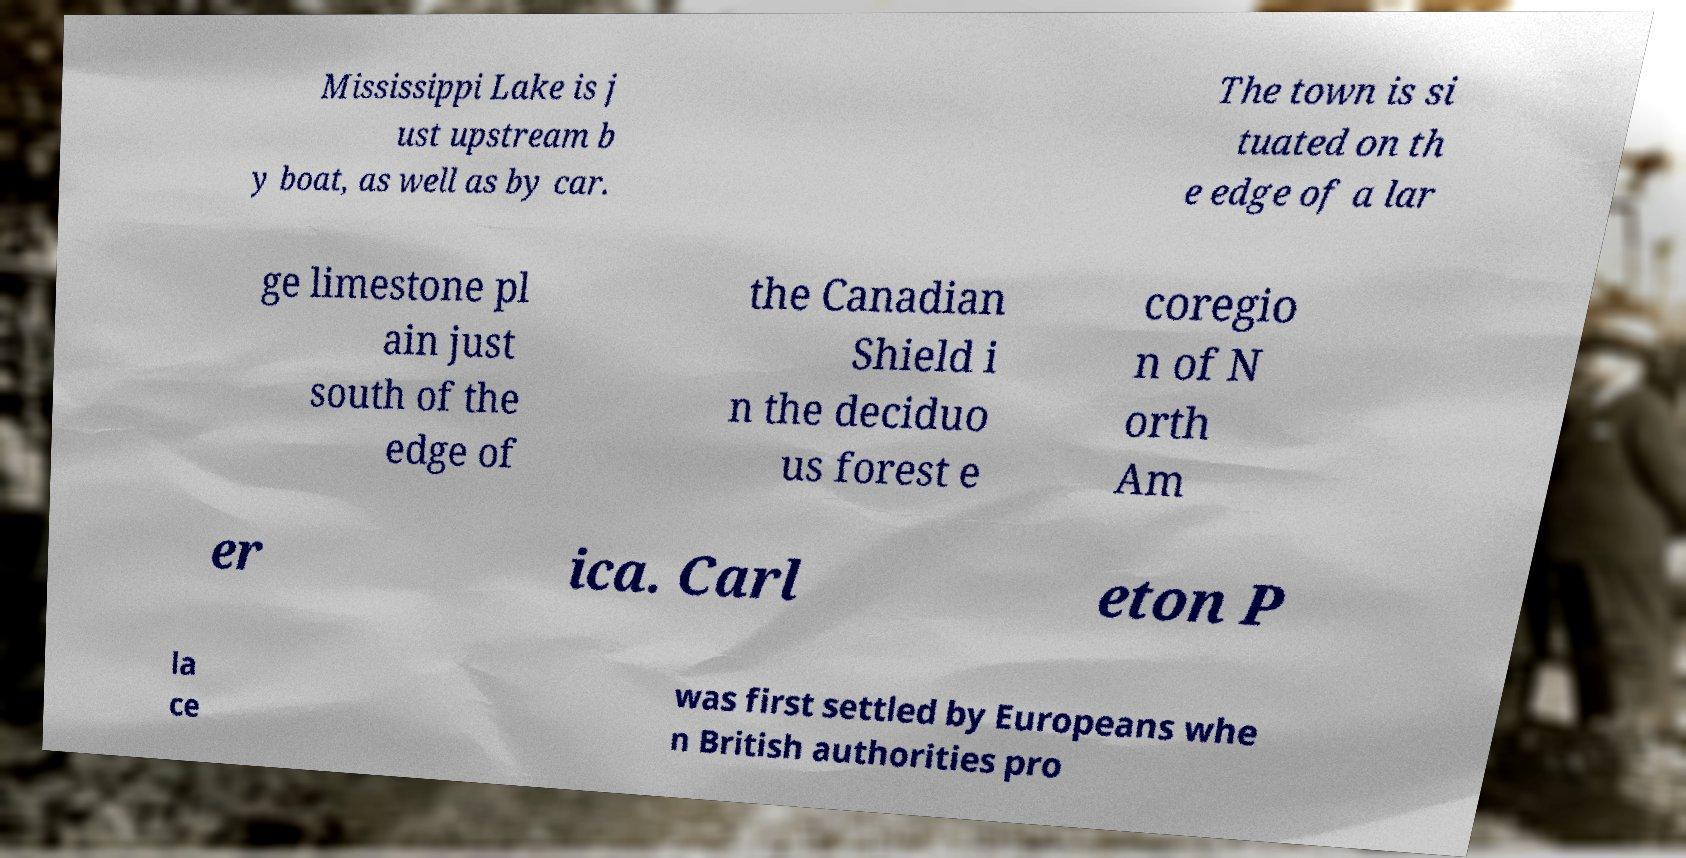There's text embedded in this image that I need extracted. Can you transcribe it verbatim? Mississippi Lake is j ust upstream b y boat, as well as by car. The town is si tuated on th e edge of a lar ge limestone pl ain just south of the edge of the Canadian Shield i n the deciduo us forest e coregio n of N orth Am er ica. Carl eton P la ce was first settled by Europeans whe n British authorities pro 